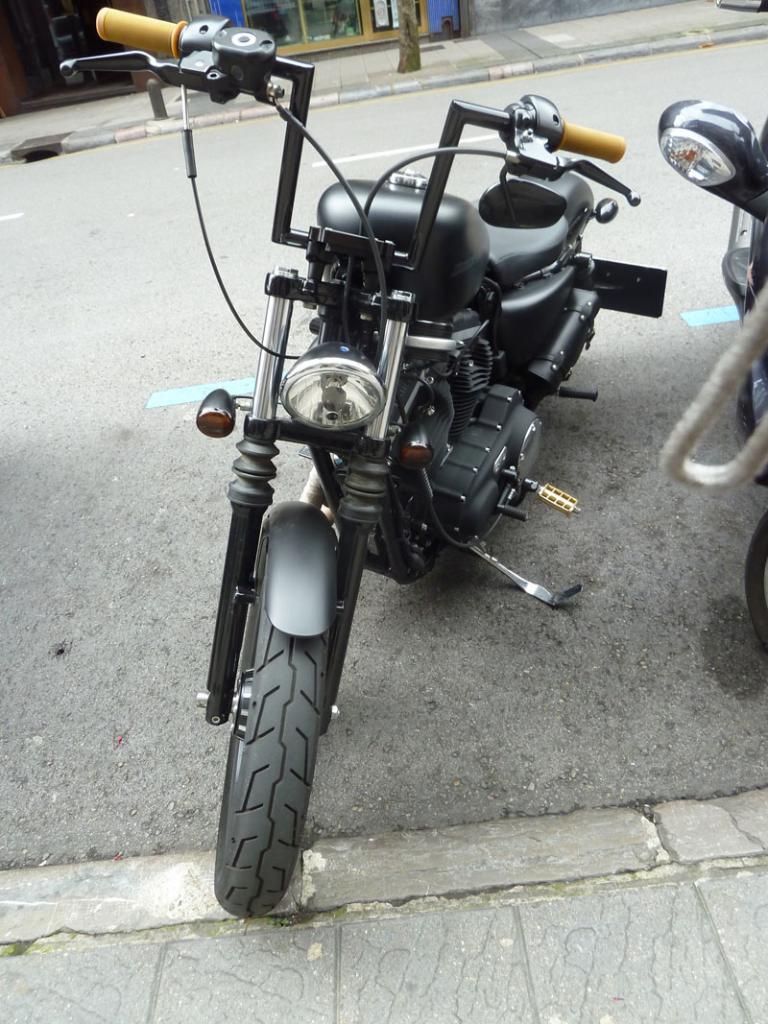Can you describe this image briefly? In this image in the front there are bikes on the road. In the background there is a tree and there is a building. 